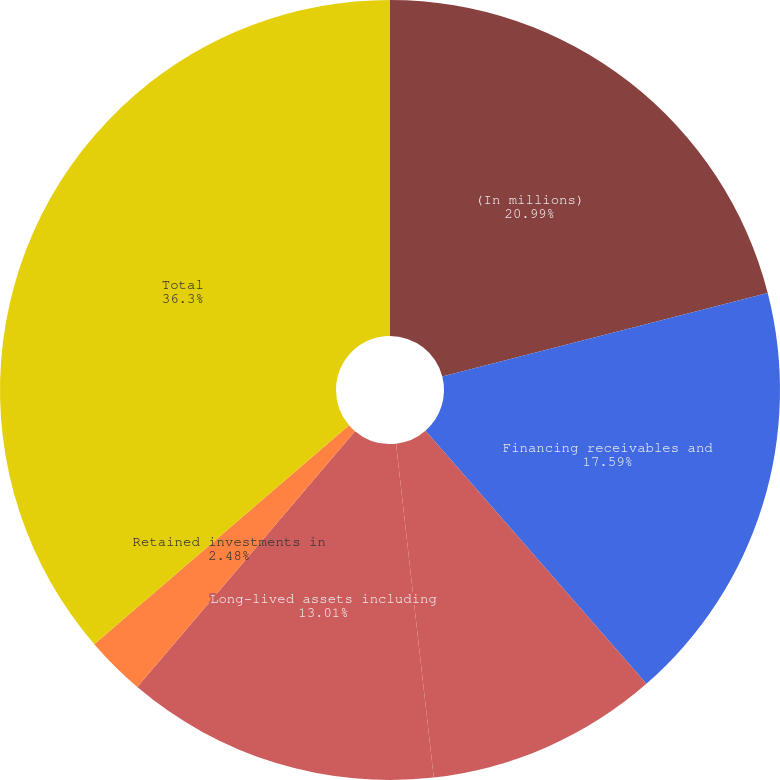Convert chart. <chart><loc_0><loc_0><loc_500><loc_500><pie_chart><fcel>(In millions)<fcel>Financing receivables and<fcel>Cost and equity method<fcel>Long-lived assets including<fcel>Retained investments in<fcel>Total<nl><fcel>21.0%<fcel>17.59%<fcel>9.63%<fcel>13.01%<fcel>2.48%<fcel>36.31%<nl></chart> 